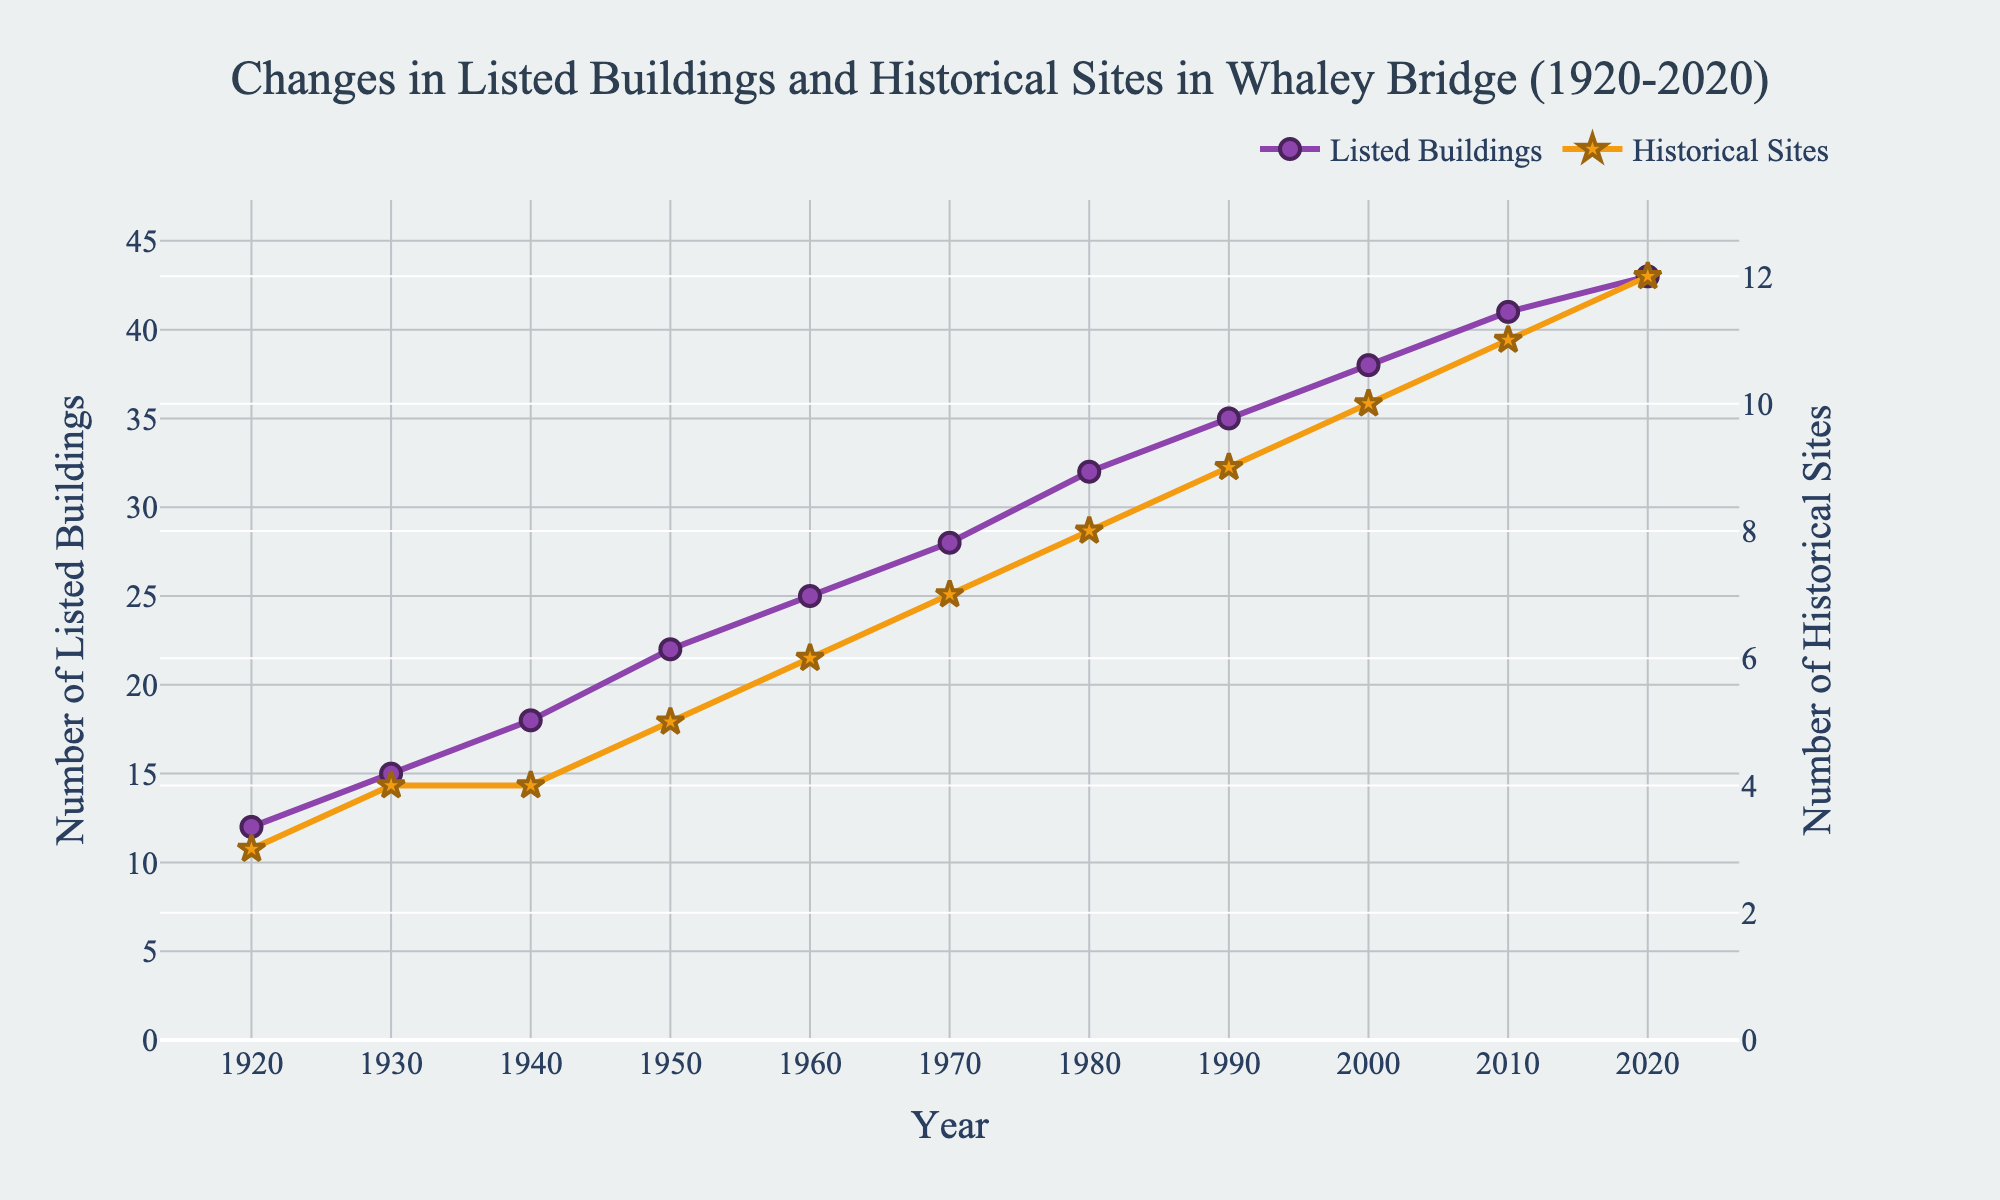What is the total number of listed buildings and historical sites in Whaley Bridge in 2020? The number of listed buildings in 2020 is 43 and the number of historical sites is 12. Adding them together, we get 43 + 12 = 55
Answer: 55 How did the number of listed buildings change from 1950 to 1980? In 1950, there were 22 listed buildings, and by 1980, the number had increased to 32. The change is calculated as 32 - 22 = 10
Answer: 10 By how many did the number of historical sites grow between 1940 and 2020? The number of historical sites in 1940 was 4 and it increased to 12 by 2020. The growth is therefore 12 - 4 = 8
Answer: 8 Which year saw a greater increase in the number of listed buildings: 1960-1970 or 1990-2000? From 1960 to 1970, the number of listed buildings increased from 25 to 28, giving a change of 28 - 25 = 3. From 1990 to 2000, the number increased from 35 to 38, giving a change of 38 - 35 = 3. Both periods saw an equal increase.
Answer: Equal increase (3) During which decade did the number of historical sites increase the most? Observing the data, the number of historical sites increased from 1960 (6) to 1970 (7), from 1970 (7) to 1980 (8), from 1980 (8) to 1990 (9), from 1990 (9) to 2000 (10), from 2000 (10) to 2010 (11), and from 2010 (11) to 2020 (12). The years where the increase was the most significant are 1950 to 1960 (from 5 to 6) and from 1980 to 1990 (8 to 9).
Answer: 1950-1960 and 1980-1990 Is the increase in the number of listed buildings proportional to the increase in the number of historical sites over the century? From 1920 to 2020, the number of listed buildings increased from 12 to 43 (a difference of 43 - 12 = 31) and the number of historical sites increased from 3 to 12 (a difference of 12 - 3 = 9). The increases are 31 and 9, respectively, which are not proportional.
Answer: Not proportional How do the trends in the increase of listed buildings and historical sites compare visually? Both trends show a gradual increase, but the number of listed buildings has a steeper, more consistent upward trend compared to the number of historical sites. This is visually evident from the steeper slope of the purple line (listed buildings) compared to the orange line (historical sites).
Answer: Steeper increase in listed buildings Which category (listed buildings or historical sites) had more variability in their increase, and how can you tell? The listed buildings show more consistent, steady growth whereas the historical sites have years where the increase is less frequent (some decades show no change). This is visually apparent from the more uniform line for listed buildings compared to the more step-like appearance of the historical sites line.
Answer: Listed buildings have steadier growth What is the sum of the number of listed buildings and historical sites in 1930 and 2020? In 1930, there were 15 listed buildings and 4 historical sites, making a total of 15 + 4 = 19. In 2020, there were 43 listed buildings and 12 historical sites, making a total of 43 + 12 = 55. Adding these totals together, 19 + 55 = 74.
Answer: 74 